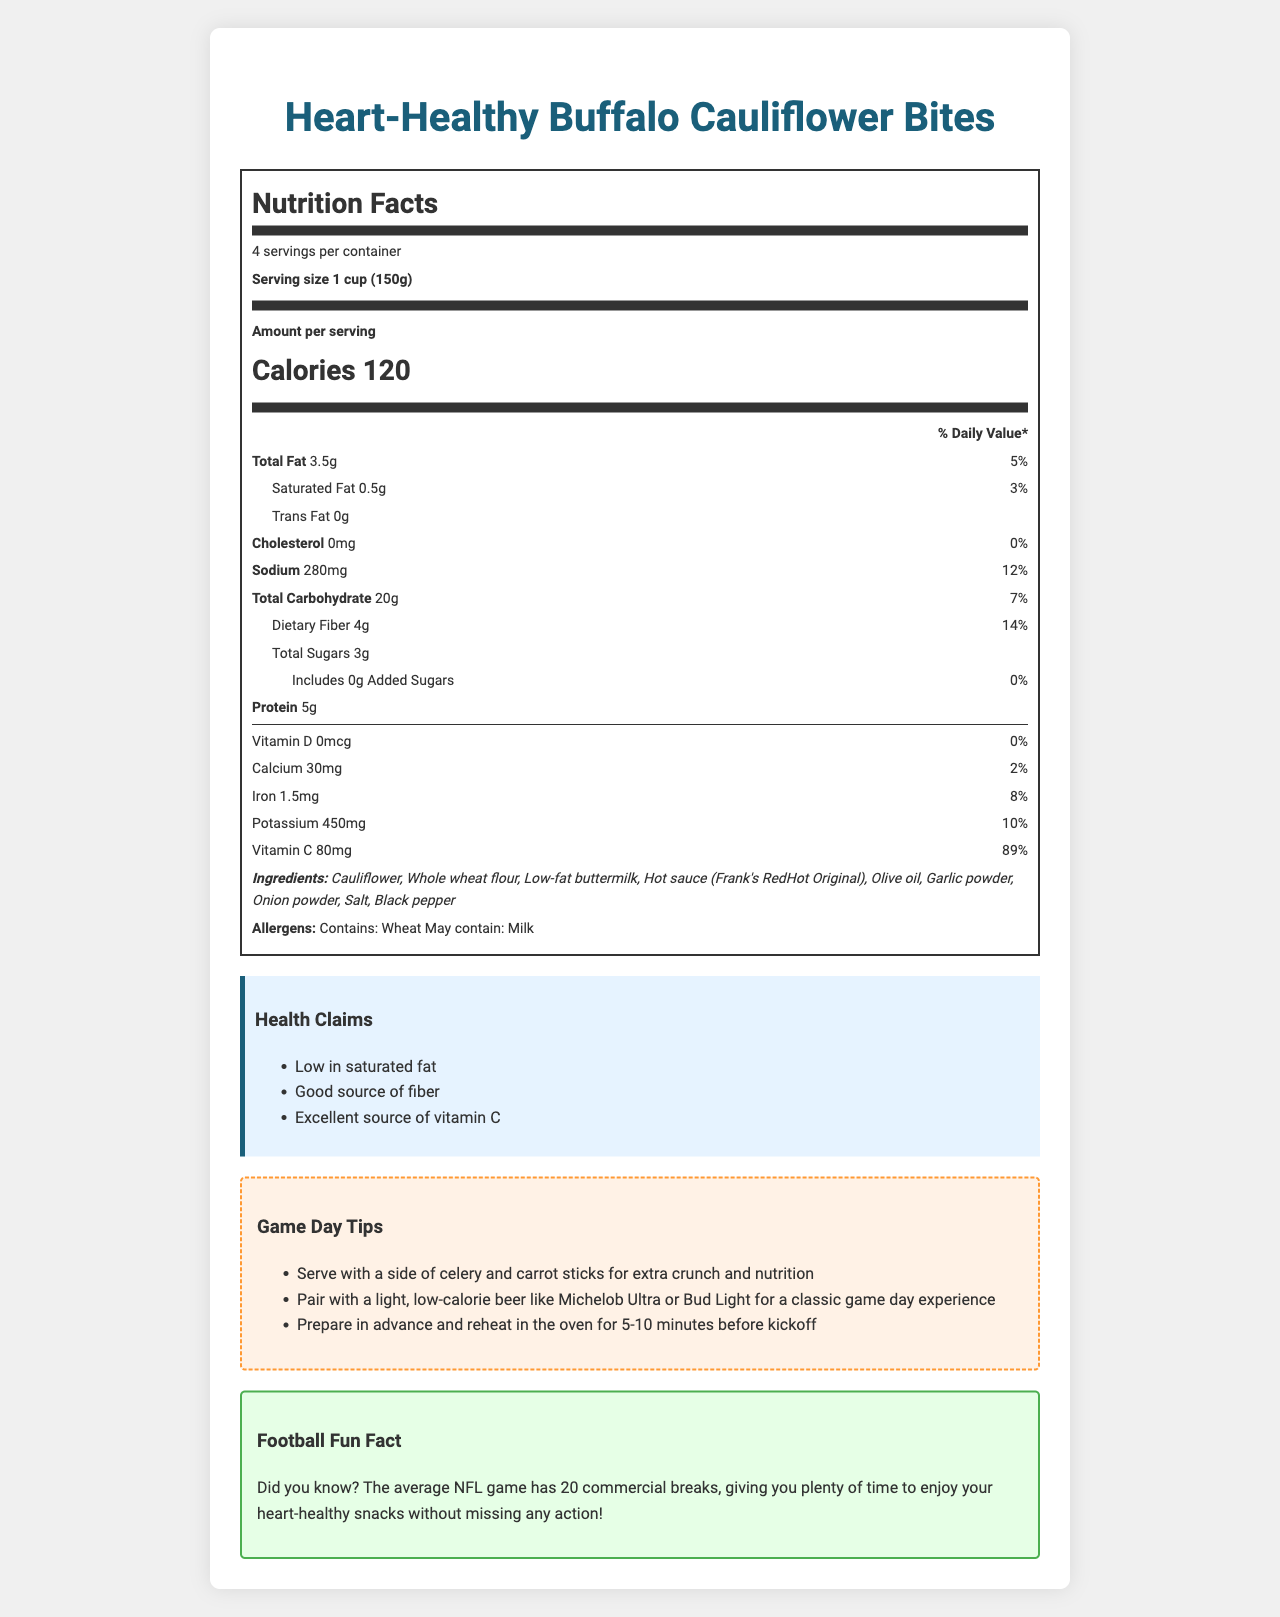what is the serving size for Heart-Healthy Buffalo Cauliflower Bites? The serving size listed in the Nutrition Facts section is 1 cup (150g).
Answer: 1 cup (150g) how many servings are there per container? The document states that there are 4 servings per container.
Answer: 4 what is the amount of saturated fat per serving? The Nutrition Facts label specifies that each serving contains 0.5g of saturated fat.
Answer: 0.5g how much sodium is in one serving? The Nutrition Facts section shows that there are 280mg of sodium per serving.
Answer: 280mg what are the main ingredients in this product? The ingredients are listed in the document under “Ingredients”.
Answer: Cauliflower, Whole wheat flour, Low-fat buttermilk, Hot sauce (Frank's RedHot Original), Olive oil, Garlic powder, Onion powder, Salt, Black pepper which of the following health claims are made about this product? A. High in protein B. Low in saturated fat C. Contains trans fat D. High in calories The document lists "Low in saturated fat" among the health claims.
Answer: B what is an excellent source of vitamin C for heart health? A. Olive oil B. Whole wheat flour C. Buffalo Cauliflower Bites D. Low-fat buttermilk The document states that the Heart-Healthy Buffalo Cauliflower Bites are an "Excellent source of vitamin C".
Answer: C is there any cholesterol in these Buffalo Cauliflower Bites? The Nutrition Facts label shows that there is 0 mg of cholesterol per serving.
Answer: No summarize the main point of the document. The document is primarily about presenting nutritional facts and additional info for the Heart-Healthy Buffalo Cauliflower Bites, focusing on their health benefits and suitability as a game day snack.
Answer: The document provides detailed nutritional information for Heart-Healthy Buffalo Cauliflower Bites, highlighting its low saturated fat content, good fiber source, and vitamin C, making it a heart-healthy game day appetizer. The document includes ingredients, allergens, health claims, preparation and storage instructions, along with some game day tips and a fun football fact. how many commercial breaks does the average NFL game have? The fun football fact section states that the average NFL game has 20 commercial breaks.
Answer: 20 what's the total amount of protein if you consume the entire container? Each serving has 5g of protein and there are 4 servings per container, so 5g * 4 servings = 20g.
Answer: 20g does the product contain any allergens? The document mentions that the product contains wheat and may contain milk, listed under “Allergens”.
Answer: Yes how much vitamin D does one serving provide? A. 5% B. 2% C. 0% D. 10% The document states that one serving contains 0% of the daily value of vitamin D.
Answer: C how should you store this product after opening? The storage instructions specify to keep the product refrigerated and consume it within 3 days of opening.
Answer: Keep refrigerated. Consume within 3 days of opening. does the product contain any added sugars? The Nutrition Facts label lists the amount of added sugars as 0g.
Answer: No what is the main benefit of using olive oil in this recipe? The heart-healthy benefits section mentions that olive oil is used instead of butter for its monounsaturated fats beneficial for heart health.
Answer: Uses olive oil instead of butter for heart-healthy monounsaturated fats what does flipping halfway through baking time achieve? The document provides the preparation instruction to flip halfway through baking, but it does not explain the specific benefit or purpose of this action.
Answer: Cannot be determined 